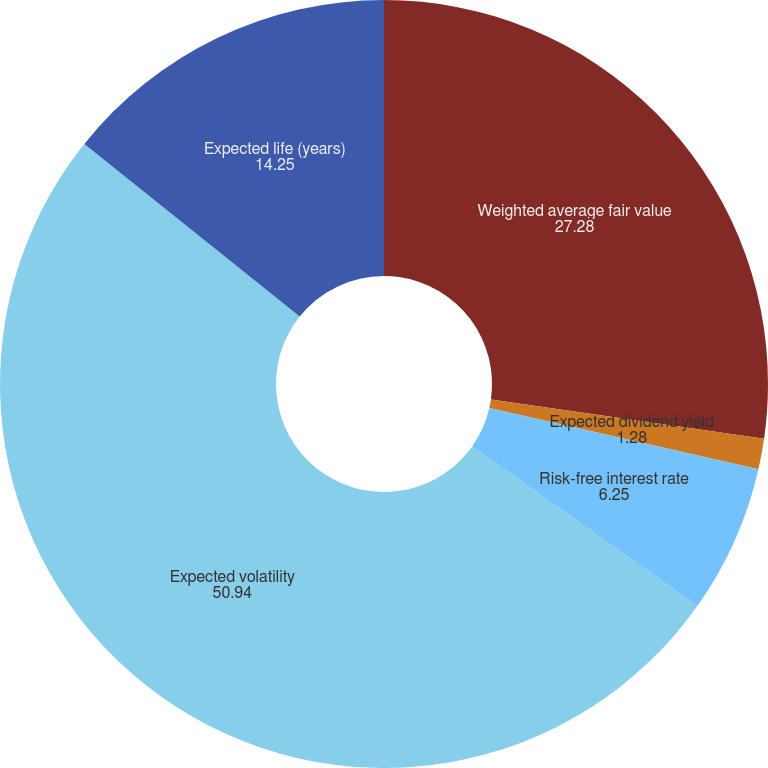Convert chart to OTSL. <chart><loc_0><loc_0><loc_500><loc_500><pie_chart><fcel>Weighted average fair value<fcel>Expected dividend yield<fcel>Risk-free interest rate<fcel>Expected volatility<fcel>Expected life (years)<nl><fcel>27.28%<fcel>1.28%<fcel>6.25%<fcel>50.94%<fcel>14.25%<nl></chart> 